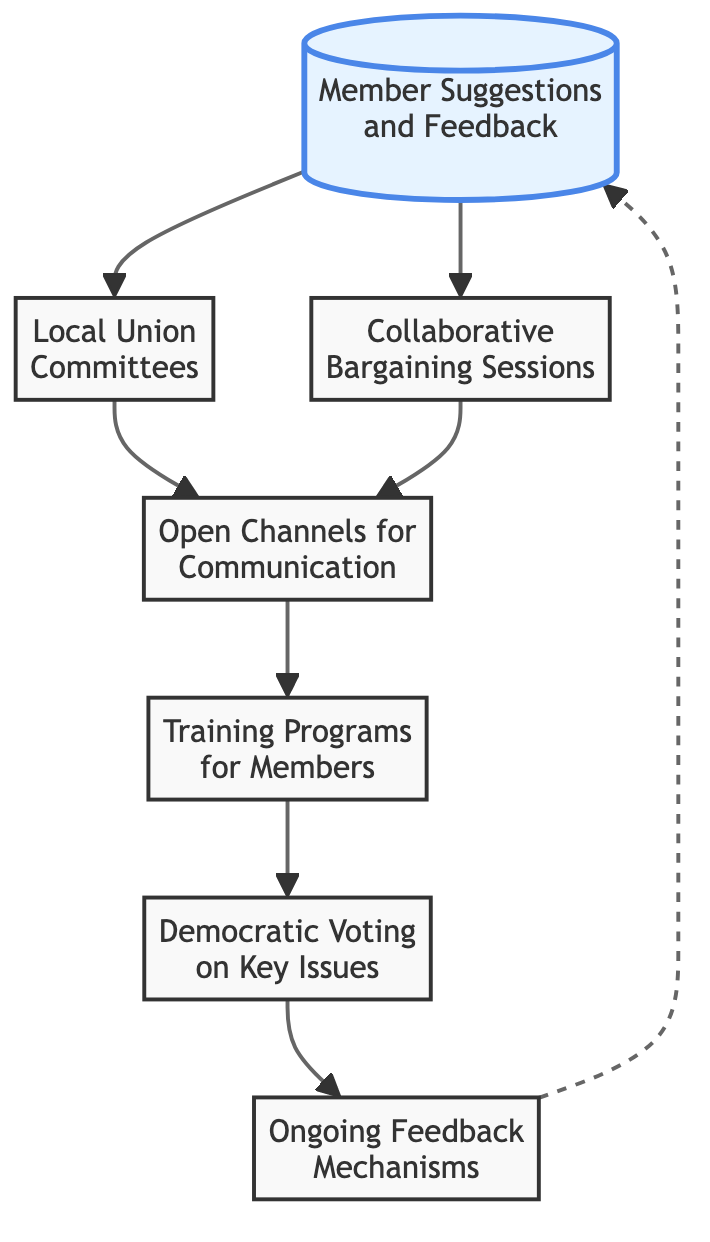What is the first node in the flow chart? The first node is connected to the flow chart's origin and represents the initial input from members, which is "Member Suggestions and Feedback."
Answer: Member Suggestions and Feedback How many nodes are in the diagram? Counting all unique elements in the diagram, we find a total of 7 nodes present in the flow chart.
Answer: 7 What node follows "Collaborative Bargaining Sessions" in the flow chart? Following the node "Collaborative Bargaining Sessions," the next node in the flow is "Open Channels for Communication."
Answer: Open Channels for Communication Which node represents ongoing member feedback mechanisms? The node dedicated to this concept is labeled "Ongoing Feedback Mechanisms," which indicates a continual process for member input post-decisions.
Answer: Ongoing Feedback Mechanisms What type of training is indicated in the flow chart? The diagram specifies "Training Programs for Members" which suggests a focus on educating union members.
Answer: Training Programs for Members What is the connection between "Member Voting" and "Ongoing Feedback Mechanisms"? "Member Voting" directly leads to "Ongoing Feedback Mechanisms," indicating that voting outcomes contribute to continuous feedback systems.
Answer: Direct connection What element primarily ensures members' voices are heard? The element that facilitates this concept is "Democratic Voting on Key Issues," as it explicitly involves member participation in decision-making.
Answer: Democratic Voting on Key Issues How do "Local Union Committees" relate to "Open Channels for Communication"? "Local Union Committees" provide input that links to "Open Channels for Communication," revealing that local committees help facilitate communication pathways.
Answer: Provide input 